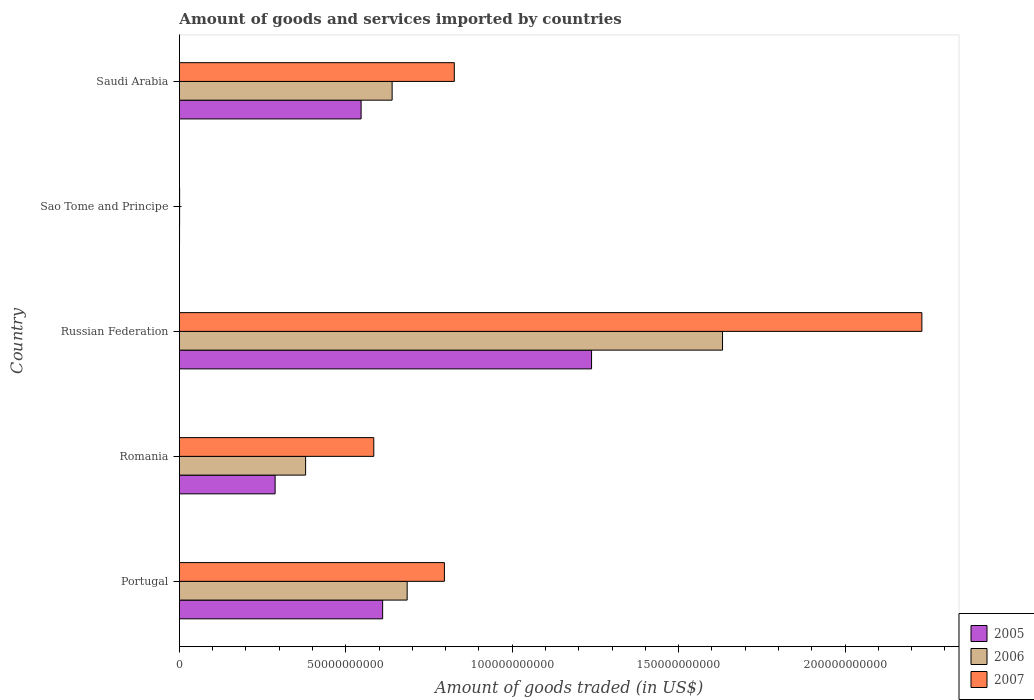How many groups of bars are there?
Offer a terse response. 5. Are the number of bars on each tick of the Y-axis equal?
Provide a succinct answer. Yes. How many bars are there on the 5th tick from the top?
Your response must be concise. 3. How many bars are there on the 3rd tick from the bottom?
Give a very brief answer. 3. What is the label of the 1st group of bars from the top?
Provide a succinct answer. Saudi Arabia. What is the total amount of goods and services imported in 2007 in Saudi Arabia?
Your response must be concise. 8.26e+1. Across all countries, what is the maximum total amount of goods and services imported in 2007?
Make the answer very short. 2.23e+11. Across all countries, what is the minimum total amount of goods and services imported in 2006?
Give a very brief answer. 5.92e+07. In which country was the total amount of goods and services imported in 2007 maximum?
Your answer should be very brief. Russian Federation. In which country was the total amount of goods and services imported in 2005 minimum?
Your answer should be very brief. Sao Tome and Principe. What is the total total amount of goods and services imported in 2006 in the graph?
Make the answer very short. 3.34e+11. What is the difference between the total amount of goods and services imported in 2007 in Portugal and that in Russian Federation?
Make the answer very short. -1.43e+11. What is the difference between the total amount of goods and services imported in 2005 in Romania and the total amount of goods and services imported in 2006 in Saudi Arabia?
Your answer should be very brief. -3.52e+1. What is the average total amount of goods and services imported in 2005 per country?
Your answer should be compact. 5.37e+1. What is the difference between the total amount of goods and services imported in 2005 and total amount of goods and services imported in 2007 in Sao Tome and Principe?
Ensure brevity in your answer.  -2.33e+07. In how many countries, is the total amount of goods and services imported in 2005 greater than 40000000000 US$?
Give a very brief answer. 3. What is the ratio of the total amount of goods and services imported in 2006 in Portugal to that in Romania?
Offer a very short reply. 1.8. Is the total amount of goods and services imported in 2005 in Romania less than that in Sao Tome and Principe?
Give a very brief answer. No. What is the difference between the highest and the second highest total amount of goods and services imported in 2007?
Offer a very short reply. 1.40e+11. What is the difference between the highest and the lowest total amount of goods and services imported in 2007?
Make the answer very short. 2.23e+11. Is the sum of the total amount of goods and services imported in 2007 in Portugal and Romania greater than the maximum total amount of goods and services imported in 2006 across all countries?
Provide a succinct answer. No. What does the 2nd bar from the top in Russian Federation represents?
Give a very brief answer. 2006. What does the 1st bar from the bottom in Portugal represents?
Offer a terse response. 2005. Is it the case that in every country, the sum of the total amount of goods and services imported in 2006 and total amount of goods and services imported in 2005 is greater than the total amount of goods and services imported in 2007?
Your answer should be compact. Yes. Are all the bars in the graph horizontal?
Provide a short and direct response. Yes. How many countries are there in the graph?
Provide a succinct answer. 5. What is the difference between two consecutive major ticks on the X-axis?
Ensure brevity in your answer.  5.00e+1. Does the graph contain any zero values?
Make the answer very short. No. Does the graph contain grids?
Your response must be concise. No. Where does the legend appear in the graph?
Your answer should be compact. Bottom right. What is the title of the graph?
Offer a very short reply. Amount of goods and services imported by countries. Does "2005" appear as one of the legend labels in the graph?
Provide a succinct answer. Yes. What is the label or title of the X-axis?
Offer a terse response. Amount of goods traded (in US$). What is the Amount of goods traded (in US$) in 2005 in Portugal?
Make the answer very short. 6.11e+1. What is the Amount of goods traded (in US$) of 2006 in Portugal?
Ensure brevity in your answer.  6.84e+1. What is the Amount of goods traded (in US$) of 2007 in Portugal?
Give a very brief answer. 7.96e+1. What is the Amount of goods traded (in US$) of 2005 in Romania?
Provide a succinct answer. 2.88e+1. What is the Amount of goods traded (in US$) of 2006 in Romania?
Ensure brevity in your answer.  3.79e+1. What is the Amount of goods traded (in US$) in 2007 in Romania?
Your response must be concise. 5.84e+1. What is the Amount of goods traded (in US$) in 2005 in Russian Federation?
Provide a succinct answer. 1.24e+11. What is the Amount of goods traded (in US$) in 2006 in Russian Federation?
Make the answer very short. 1.63e+11. What is the Amount of goods traded (in US$) in 2007 in Russian Federation?
Your answer should be compact. 2.23e+11. What is the Amount of goods traded (in US$) in 2005 in Sao Tome and Principe?
Provide a succinct answer. 4.16e+07. What is the Amount of goods traded (in US$) in 2006 in Sao Tome and Principe?
Make the answer very short. 5.92e+07. What is the Amount of goods traded (in US$) of 2007 in Sao Tome and Principe?
Offer a very short reply. 6.49e+07. What is the Amount of goods traded (in US$) in 2005 in Saudi Arabia?
Provide a short and direct response. 5.46e+1. What is the Amount of goods traded (in US$) in 2006 in Saudi Arabia?
Give a very brief answer. 6.39e+1. What is the Amount of goods traded (in US$) in 2007 in Saudi Arabia?
Give a very brief answer. 8.26e+1. Across all countries, what is the maximum Amount of goods traded (in US$) in 2005?
Provide a succinct answer. 1.24e+11. Across all countries, what is the maximum Amount of goods traded (in US$) in 2006?
Your answer should be compact. 1.63e+11. Across all countries, what is the maximum Amount of goods traded (in US$) of 2007?
Provide a succinct answer. 2.23e+11. Across all countries, what is the minimum Amount of goods traded (in US$) of 2005?
Offer a very short reply. 4.16e+07. Across all countries, what is the minimum Amount of goods traded (in US$) of 2006?
Offer a very short reply. 5.92e+07. Across all countries, what is the minimum Amount of goods traded (in US$) in 2007?
Provide a succinct answer. 6.49e+07. What is the total Amount of goods traded (in US$) of 2005 in the graph?
Offer a very short reply. 2.68e+11. What is the total Amount of goods traded (in US$) in 2006 in the graph?
Provide a succinct answer. 3.34e+11. What is the total Amount of goods traded (in US$) of 2007 in the graph?
Provide a succinct answer. 4.44e+11. What is the difference between the Amount of goods traded (in US$) in 2005 in Portugal and that in Romania?
Provide a short and direct response. 3.23e+1. What is the difference between the Amount of goods traded (in US$) in 2006 in Portugal and that in Romania?
Offer a very short reply. 3.05e+1. What is the difference between the Amount of goods traded (in US$) of 2007 in Portugal and that in Romania?
Ensure brevity in your answer.  2.12e+1. What is the difference between the Amount of goods traded (in US$) of 2005 in Portugal and that in Russian Federation?
Your answer should be compact. -6.28e+1. What is the difference between the Amount of goods traded (in US$) of 2006 in Portugal and that in Russian Federation?
Your response must be concise. -9.48e+1. What is the difference between the Amount of goods traded (in US$) of 2007 in Portugal and that in Russian Federation?
Provide a succinct answer. -1.43e+11. What is the difference between the Amount of goods traded (in US$) in 2005 in Portugal and that in Sao Tome and Principe?
Keep it short and to the point. 6.10e+1. What is the difference between the Amount of goods traded (in US$) of 2006 in Portugal and that in Sao Tome and Principe?
Keep it short and to the point. 6.84e+1. What is the difference between the Amount of goods traded (in US$) in 2007 in Portugal and that in Sao Tome and Principe?
Make the answer very short. 7.96e+1. What is the difference between the Amount of goods traded (in US$) in 2005 in Portugal and that in Saudi Arabia?
Provide a short and direct response. 6.47e+09. What is the difference between the Amount of goods traded (in US$) of 2006 in Portugal and that in Saudi Arabia?
Offer a very short reply. 4.51e+09. What is the difference between the Amount of goods traded (in US$) of 2007 in Portugal and that in Saudi Arabia?
Ensure brevity in your answer.  -2.98e+09. What is the difference between the Amount of goods traded (in US$) in 2005 in Romania and that in Russian Federation?
Ensure brevity in your answer.  -9.51e+1. What is the difference between the Amount of goods traded (in US$) of 2006 in Romania and that in Russian Federation?
Provide a succinct answer. -1.25e+11. What is the difference between the Amount of goods traded (in US$) in 2007 in Romania and that in Russian Federation?
Provide a short and direct response. -1.65e+11. What is the difference between the Amount of goods traded (in US$) in 2005 in Romania and that in Sao Tome and Principe?
Provide a short and direct response. 2.87e+1. What is the difference between the Amount of goods traded (in US$) in 2006 in Romania and that in Sao Tome and Principe?
Make the answer very short. 3.79e+1. What is the difference between the Amount of goods traded (in US$) of 2007 in Romania and that in Sao Tome and Principe?
Your answer should be very brief. 5.83e+1. What is the difference between the Amount of goods traded (in US$) of 2005 in Romania and that in Saudi Arabia?
Offer a very short reply. -2.58e+1. What is the difference between the Amount of goods traded (in US$) in 2006 in Romania and that in Saudi Arabia?
Offer a very short reply. -2.60e+1. What is the difference between the Amount of goods traded (in US$) of 2007 in Romania and that in Saudi Arabia?
Provide a short and direct response. -2.42e+1. What is the difference between the Amount of goods traded (in US$) of 2005 in Russian Federation and that in Sao Tome and Principe?
Make the answer very short. 1.24e+11. What is the difference between the Amount of goods traded (in US$) in 2006 in Russian Federation and that in Sao Tome and Principe?
Your answer should be compact. 1.63e+11. What is the difference between the Amount of goods traded (in US$) of 2007 in Russian Federation and that in Sao Tome and Principe?
Offer a very short reply. 2.23e+11. What is the difference between the Amount of goods traded (in US$) of 2005 in Russian Federation and that in Saudi Arabia?
Make the answer very short. 6.92e+1. What is the difference between the Amount of goods traded (in US$) of 2006 in Russian Federation and that in Saudi Arabia?
Give a very brief answer. 9.93e+1. What is the difference between the Amount of goods traded (in US$) of 2007 in Russian Federation and that in Saudi Arabia?
Make the answer very short. 1.40e+11. What is the difference between the Amount of goods traded (in US$) in 2005 in Sao Tome and Principe and that in Saudi Arabia?
Your answer should be compact. -5.46e+1. What is the difference between the Amount of goods traded (in US$) of 2006 in Sao Tome and Principe and that in Saudi Arabia?
Make the answer very short. -6.39e+1. What is the difference between the Amount of goods traded (in US$) of 2007 in Sao Tome and Principe and that in Saudi Arabia?
Give a very brief answer. -8.25e+1. What is the difference between the Amount of goods traded (in US$) of 2005 in Portugal and the Amount of goods traded (in US$) of 2006 in Romania?
Keep it short and to the point. 2.31e+1. What is the difference between the Amount of goods traded (in US$) of 2005 in Portugal and the Amount of goods traded (in US$) of 2007 in Romania?
Offer a terse response. 2.66e+09. What is the difference between the Amount of goods traded (in US$) in 2006 in Portugal and the Amount of goods traded (in US$) in 2007 in Romania?
Your response must be concise. 1.00e+1. What is the difference between the Amount of goods traded (in US$) in 2005 in Portugal and the Amount of goods traded (in US$) in 2006 in Russian Federation?
Provide a short and direct response. -1.02e+11. What is the difference between the Amount of goods traded (in US$) in 2005 in Portugal and the Amount of goods traded (in US$) in 2007 in Russian Federation?
Keep it short and to the point. -1.62e+11. What is the difference between the Amount of goods traded (in US$) in 2006 in Portugal and the Amount of goods traded (in US$) in 2007 in Russian Federation?
Offer a very short reply. -1.55e+11. What is the difference between the Amount of goods traded (in US$) of 2005 in Portugal and the Amount of goods traded (in US$) of 2006 in Sao Tome and Principe?
Provide a short and direct response. 6.10e+1. What is the difference between the Amount of goods traded (in US$) of 2005 in Portugal and the Amount of goods traded (in US$) of 2007 in Sao Tome and Principe?
Offer a terse response. 6.10e+1. What is the difference between the Amount of goods traded (in US$) of 2006 in Portugal and the Amount of goods traded (in US$) of 2007 in Sao Tome and Principe?
Make the answer very short. 6.84e+1. What is the difference between the Amount of goods traded (in US$) in 2005 in Portugal and the Amount of goods traded (in US$) in 2006 in Saudi Arabia?
Provide a short and direct response. -2.85e+09. What is the difference between the Amount of goods traded (in US$) in 2005 in Portugal and the Amount of goods traded (in US$) in 2007 in Saudi Arabia?
Offer a terse response. -2.15e+1. What is the difference between the Amount of goods traded (in US$) of 2006 in Portugal and the Amount of goods traded (in US$) of 2007 in Saudi Arabia?
Provide a succinct answer. -1.42e+1. What is the difference between the Amount of goods traded (in US$) in 2005 in Romania and the Amount of goods traded (in US$) in 2006 in Russian Federation?
Your answer should be compact. -1.34e+11. What is the difference between the Amount of goods traded (in US$) in 2005 in Romania and the Amount of goods traded (in US$) in 2007 in Russian Federation?
Your answer should be very brief. -1.94e+11. What is the difference between the Amount of goods traded (in US$) in 2006 in Romania and the Amount of goods traded (in US$) in 2007 in Russian Federation?
Offer a very short reply. -1.85e+11. What is the difference between the Amount of goods traded (in US$) of 2005 in Romania and the Amount of goods traded (in US$) of 2006 in Sao Tome and Principe?
Make the answer very short. 2.87e+1. What is the difference between the Amount of goods traded (in US$) of 2005 in Romania and the Amount of goods traded (in US$) of 2007 in Sao Tome and Principe?
Your response must be concise. 2.87e+1. What is the difference between the Amount of goods traded (in US$) of 2006 in Romania and the Amount of goods traded (in US$) of 2007 in Sao Tome and Principe?
Your answer should be compact. 3.79e+1. What is the difference between the Amount of goods traded (in US$) of 2005 in Romania and the Amount of goods traded (in US$) of 2006 in Saudi Arabia?
Keep it short and to the point. -3.52e+1. What is the difference between the Amount of goods traded (in US$) in 2005 in Romania and the Amount of goods traded (in US$) in 2007 in Saudi Arabia?
Provide a succinct answer. -5.38e+1. What is the difference between the Amount of goods traded (in US$) in 2006 in Romania and the Amount of goods traded (in US$) in 2007 in Saudi Arabia?
Your answer should be compact. -4.47e+1. What is the difference between the Amount of goods traded (in US$) of 2005 in Russian Federation and the Amount of goods traded (in US$) of 2006 in Sao Tome and Principe?
Provide a short and direct response. 1.24e+11. What is the difference between the Amount of goods traded (in US$) in 2005 in Russian Federation and the Amount of goods traded (in US$) in 2007 in Sao Tome and Principe?
Your response must be concise. 1.24e+11. What is the difference between the Amount of goods traded (in US$) of 2006 in Russian Federation and the Amount of goods traded (in US$) of 2007 in Sao Tome and Principe?
Keep it short and to the point. 1.63e+11. What is the difference between the Amount of goods traded (in US$) of 2005 in Russian Federation and the Amount of goods traded (in US$) of 2006 in Saudi Arabia?
Your answer should be compact. 5.99e+1. What is the difference between the Amount of goods traded (in US$) of 2005 in Russian Federation and the Amount of goods traded (in US$) of 2007 in Saudi Arabia?
Your answer should be compact. 4.12e+1. What is the difference between the Amount of goods traded (in US$) in 2006 in Russian Federation and the Amount of goods traded (in US$) in 2007 in Saudi Arabia?
Give a very brief answer. 8.06e+1. What is the difference between the Amount of goods traded (in US$) in 2005 in Sao Tome and Principe and the Amount of goods traded (in US$) in 2006 in Saudi Arabia?
Your answer should be very brief. -6.39e+1. What is the difference between the Amount of goods traded (in US$) in 2005 in Sao Tome and Principe and the Amount of goods traded (in US$) in 2007 in Saudi Arabia?
Provide a short and direct response. -8.26e+1. What is the difference between the Amount of goods traded (in US$) of 2006 in Sao Tome and Principe and the Amount of goods traded (in US$) of 2007 in Saudi Arabia?
Offer a terse response. -8.25e+1. What is the average Amount of goods traded (in US$) in 2005 per country?
Keep it short and to the point. 5.37e+1. What is the average Amount of goods traded (in US$) of 2006 per country?
Provide a succinct answer. 6.67e+1. What is the average Amount of goods traded (in US$) in 2007 per country?
Give a very brief answer. 8.88e+1. What is the difference between the Amount of goods traded (in US$) of 2005 and Amount of goods traded (in US$) of 2006 in Portugal?
Ensure brevity in your answer.  -7.37e+09. What is the difference between the Amount of goods traded (in US$) in 2005 and Amount of goods traded (in US$) in 2007 in Portugal?
Your response must be concise. -1.86e+1. What is the difference between the Amount of goods traded (in US$) in 2006 and Amount of goods traded (in US$) in 2007 in Portugal?
Your answer should be compact. -1.12e+1. What is the difference between the Amount of goods traded (in US$) of 2005 and Amount of goods traded (in US$) of 2006 in Romania?
Provide a succinct answer. -9.16e+09. What is the difference between the Amount of goods traded (in US$) in 2005 and Amount of goods traded (in US$) in 2007 in Romania?
Ensure brevity in your answer.  -2.96e+1. What is the difference between the Amount of goods traded (in US$) of 2006 and Amount of goods traded (in US$) of 2007 in Romania?
Offer a very short reply. -2.05e+1. What is the difference between the Amount of goods traded (in US$) in 2005 and Amount of goods traded (in US$) in 2006 in Russian Federation?
Provide a succinct answer. -3.93e+1. What is the difference between the Amount of goods traded (in US$) of 2005 and Amount of goods traded (in US$) of 2007 in Russian Federation?
Keep it short and to the point. -9.92e+1. What is the difference between the Amount of goods traded (in US$) of 2006 and Amount of goods traded (in US$) of 2007 in Russian Federation?
Offer a terse response. -5.99e+1. What is the difference between the Amount of goods traded (in US$) in 2005 and Amount of goods traded (in US$) in 2006 in Sao Tome and Principe?
Make the answer very short. -1.76e+07. What is the difference between the Amount of goods traded (in US$) of 2005 and Amount of goods traded (in US$) of 2007 in Sao Tome and Principe?
Offer a very short reply. -2.33e+07. What is the difference between the Amount of goods traded (in US$) of 2006 and Amount of goods traded (in US$) of 2007 in Sao Tome and Principe?
Provide a short and direct response. -5.63e+06. What is the difference between the Amount of goods traded (in US$) in 2005 and Amount of goods traded (in US$) in 2006 in Saudi Arabia?
Provide a short and direct response. -9.32e+09. What is the difference between the Amount of goods traded (in US$) in 2005 and Amount of goods traded (in US$) in 2007 in Saudi Arabia?
Your answer should be very brief. -2.80e+1. What is the difference between the Amount of goods traded (in US$) of 2006 and Amount of goods traded (in US$) of 2007 in Saudi Arabia?
Make the answer very short. -1.87e+1. What is the ratio of the Amount of goods traded (in US$) in 2005 in Portugal to that in Romania?
Your answer should be compact. 2.12. What is the ratio of the Amount of goods traded (in US$) in 2006 in Portugal to that in Romania?
Your answer should be very brief. 1.8. What is the ratio of the Amount of goods traded (in US$) in 2007 in Portugal to that in Romania?
Give a very brief answer. 1.36. What is the ratio of the Amount of goods traded (in US$) in 2005 in Portugal to that in Russian Federation?
Give a very brief answer. 0.49. What is the ratio of the Amount of goods traded (in US$) of 2006 in Portugal to that in Russian Federation?
Your answer should be compact. 0.42. What is the ratio of the Amount of goods traded (in US$) of 2007 in Portugal to that in Russian Federation?
Provide a short and direct response. 0.36. What is the ratio of the Amount of goods traded (in US$) of 2005 in Portugal to that in Sao Tome and Principe?
Provide a short and direct response. 1467.84. What is the ratio of the Amount of goods traded (in US$) in 2006 in Portugal to that in Sao Tome and Principe?
Your answer should be compact. 1155.1. What is the ratio of the Amount of goods traded (in US$) in 2007 in Portugal to that in Sao Tome and Principe?
Provide a short and direct response. 1227.43. What is the ratio of the Amount of goods traded (in US$) of 2005 in Portugal to that in Saudi Arabia?
Offer a very short reply. 1.12. What is the ratio of the Amount of goods traded (in US$) in 2006 in Portugal to that in Saudi Arabia?
Offer a terse response. 1.07. What is the ratio of the Amount of goods traded (in US$) of 2007 in Portugal to that in Saudi Arabia?
Your answer should be very brief. 0.96. What is the ratio of the Amount of goods traded (in US$) of 2005 in Romania to that in Russian Federation?
Offer a terse response. 0.23. What is the ratio of the Amount of goods traded (in US$) in 2006 in Romania to that in Russian Federation?
Provide a succinct answer. 0.23. What is the ratio of the Amount of goods traded (in US$) in 2007 in Romania to that in Russian Federation?
Keep it short and to the point. 0.26. What is the ratio of the Amount of goods traded (in US$) of 2005 in Romania to that in Sao Tome and Principe?
Your answer should be compact. 691.27. What is the ratio of the Amount of goods traded (in US$) of 2006 in Romania to that in Sao Tome and Principe?
Offer a terse response. 640.04. What is the ratio of the Amount of goods traded (in US$) of 2007 in Romania to that in Sao Tome and Principe?
Your answer should be very brief. 900.33. What is the ratio of the Amount of goods traded (in US$) in 2005 in Romania to that in Saudi Arabia?
Your response must be concise. 0.53. What is the ratio of the Amount of goods traded (in US$) in 2006 in Romania to that in Saudi Arabia?
Provide a succinct answer. 0.59. What is the ratio of the Amount of goods traded (in US$) of 2007 in Romania to that in Saudi Arabia?
Your response must be concise. 0.71. What is the ratio of the Amount of goods traded (in US$) of 2005 in Russian Federation to that in Sao Tome and Principe?
Your response must be concise. 2976.87. What is the ratio of the Amount of goods traded (in US$) of 2006 in Russian Federation to that in Sao Tome and Principe?
Give a very brief answer. 2754.69. What is the ratio of the Amount of goods traded (in US$) of 2007 in Russian Federation to that in Sao Tome and Principe?
Provide a short and direct response. 3439.14. What is the ratio of the Amount of goods traded (in US$) in 2005 in Russian Federation to that in Saudi Arabia?
Offer a very short reply. 2.27. What is the ratio of the Amount of goods traded (in US$) in 2006 in Russian Federation to that in Saudi Arabia?
Your response must be concise. 2.55. What is the ratio of the Amount of goods traded (in US$) in 2007 in Russian Federation to that in Saudi Arabia?
Give a very brief answer. 2.7. What is the ratio of the Amount of goods traded (in US$) of 2005 in Sao Tome and Principe to that in Saudi Arabia?
Provide a succinct answer. 0. What is the ratio of the Amount of goods traded (in US$) in 2006 in Sao Tome and Principe to that in Saudi Arabia?
Ensure brevity in your answer.  0. What is the ratio of the Amount of goods traded (in US$) of 2007 in Sao Tome and Principe to that in Saudi Arabia?
Ensure brevity in your answer.  0. What is the difference between the highest and the second highest Amount of goods traded (in US$) of 2005?
Offer a very short reply. 6.28e+1. What is the difference between the highest and the second highest Amount of goods traded (in US$) of 2006?
Your answer should be very brief. 9.48e+1. What is the difference between the highest and the second highest Amount of goods traded (in US$) of 2007?
Your answer should be compact. 1.40e+11. What is the difference between the highest and the lowest Amount of goods traded (in US$) in 2005?
Make the answer very short. 1.24e+11. What is the difference between the highest and the lowest Amount of goods traded (in US$) in 2006?
Keep it short and to the point. 1.63e+11. What is the difference between the highest and the lowest Amount of goods traded (in US$) of 2007?
Provide a short and direct response. 2.23e+11. 